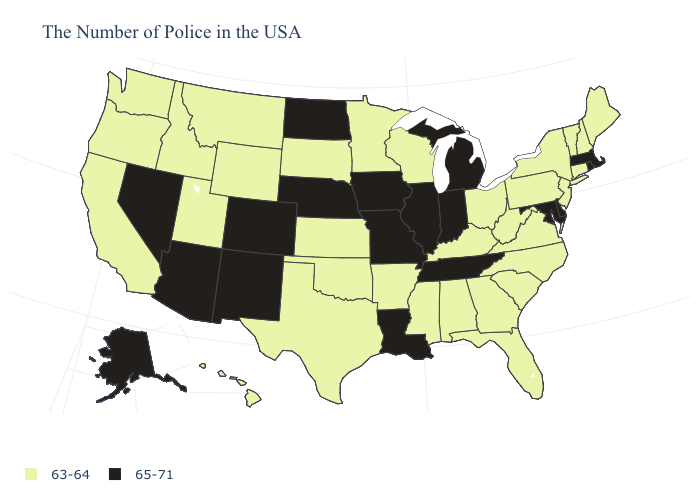Does Maryland have a higher value than Indiana?
Answer briefly. No. Does the map have missing data?
Give a very brief answer. No. What is the highest value in states that border Massachusetts?
Be succinct. 65-71. Among the states that border Vermont , which have the lowest value?
Concise answer only. New Hampshire, New York. Does Nevada have the highest value in the USA?
Give a very brief answer. Yes. Does the first symbol in the legend represent the smallest category?
Give a very brief answer. Yes. Which states have the highest value in the USA?
Answer briefly. Massachusetts, Rhode Island, Delaware, Maryland, Michigan, Indiana, Tennessee, Illinois, Louisiana, Missouri, Iowa, Nebraska, North Dakota, Colorado, New Mexico, Arizona, Nevada, Alaska. Does Virginia have the highest value in the USA?
Concise answer only. No. Name the states that have a value in the range 65-71?
Be succinct. Massachusetts, Rhode Island, Delaware, Maryland, Michigan, Indiana, Tennessee, Illinois, Louisiana, Missouri, Iowa, Nebraska, North Dakota, Colorado, New Mexico, Arizona, Nevada, Alaska. What is the value of Louisiana?
Quick response, please. 65-71. What is the lowest value in states that border South Carolina?
Short answer required. 63-64. Name the states that have a value in the range 63-64?
Concise answer only. Maine, New Hampshire, Vermont, Connecticut, New York, New Jersey, Pennsylvania, Virginia, North Carolina, South Carolina, West Virginia, Ohio, Florida, Georgia, Kentucky, Alabama, Wisconsin, Mississippi, Arkansas, Minnesota, Kansas, Oklahoma, Texas, South Dakota, Wyoming, Utah, Montana, Idaho, California, Washington, Oregon, Hawaii. Does Washington have the same value as West Virginia?
Be succinct. Yes. What is the highest value in the South ?
Keep it brief. 65-71. What is the value of Illinois?
Quick response, please. 65-71. 